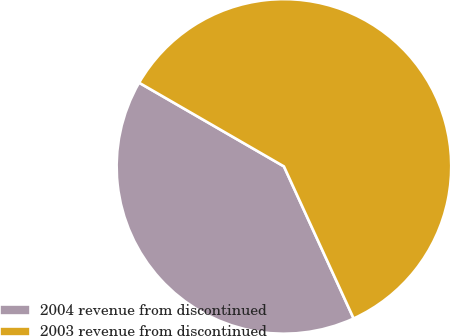Convert chart. <chart><loc_0><loc_0><loc_500><loc_500><pie_chart><fcel>2004 revenue from discontinued<fcel>2003 revenue from discontinued<nl><fcel>40.18%<fcel>59.82%<nl></chart> 